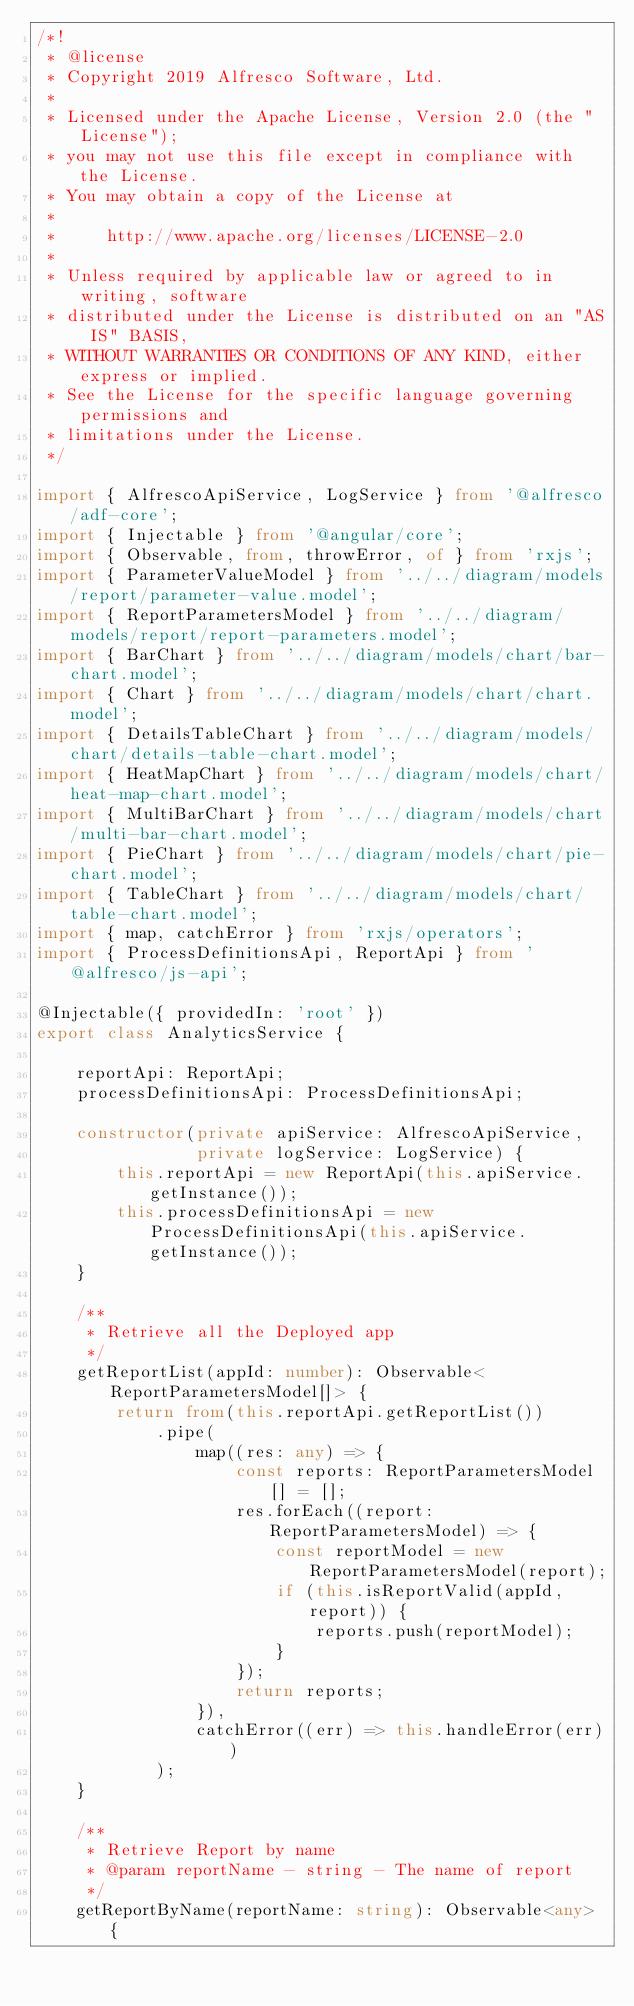Convert code to text. <code><loc_0><loc_0><loc_500><loc_500><_TypeScript_>/*!
 * @license
 * Copyright 2019 Alfresco Software, Ltd.
 *
 * Licensed under the Apache License, Version 2.0 (the "License");
 * you may not use this file except in compliance with the License.
 * You may obtain a copy of the License at
 *
 *     http://www.apache.org/licenses/LICENSE-2.0
 *
 * Unless required by applicable law or agreed to in writing, software
 * distributed under the License is distributed on an "AS IS" BASIS,
 * WITHOUT WARRANTIES OR CONDITIONS OF ANY KIND, either express or implied.
 * See the License for the specific language governing permissions and
 * limitations under the License.
 */

import { AlfrescoApiService, LogService } from '@alfresco/adf-core';
import { Injectable } from '@angular/core';
import { Observable, from, throwError, of } from 'rxjs';
import { ParameterValueModel } from '../../diagram/models/report/parameter-value.model';
import { ReportParametersModel } from '../../diagram/models/report/report-parameters.model';
import { BarChart } from '../../diagram/models/chart/bar-chart.model';
import { Chart } from '../../diagram/models/chart/chart.model';
import { DetailsTableChart } from '../../diagram/models/chart/details-table-chart.model';
import { HeatMapChart } from '../../diagram/models/chart/heat-map-chart.model';
import { MultiBarChart } from '../../diagram/models/chart/multi-bar-chart.model';
import { PieChart } from '../../diagram/models/chart/pie-chart.model';
import { TableChart } from '../../diagram/models/chart/table-chart.model';
import { map, catchError } from 'rxjs/operators';
import { ProcessDefinitionsApi, ReportApi } from '@alfresco/js-api';

@Injectable({ providedIn: 'root' })
export class AnalyticsService {

    reportApi: ReportApi;
    processDefinitionsApi: ProcessDefinitionsApi;

    constructor(private apiService: AlfrescoApiService,
                private logService: LogService) {
        this.reportApi = new ReportApi(this.apiService.getInstance());
        this.processDefinitionsApi = new ProcessDefinitionsApi(this.apiService.getInstance());
    }

    /**
     * Retrieve all the Deployed app
     */
    getReportList(appId: number): Observable<ReportParametersModel[]> {
        return from(this.reportApi.getReportList())
            .pipe(
                map((res: any) => {
                    const reports: ReportParametersModel[] = [];
                    res.forEach((report: ReportParametersModel) => {
                        const reportModel = new ReportParametersModel(report);
                        if (this.isReportValid(appId, report)) {
                            reports.push(reportModel);
                        }
                    });
                    return reports;
                }),
                catchError((err) => this.handleError(err))
            );
    }

    /**
     * Retrieve Report by name
     * @param reportName - string - The name of report
     */
    getReportByName(reportName: string): Observable<any> {</code> 